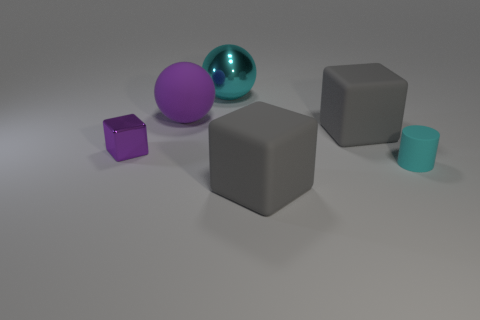There is a thing that is in front of the tiny thing that is to the right of the big matte object left of the big cyan metallic object; what shape is it?
Your answer should be compact. Cube. There is a metal object in front of the large cyan metallic sphere; is it the same color as the tiny matte thing in front of the metal cube?
Make the answer very short. No. There is a metal thing that is the same color as the large rubber ball; what shape is it?
Offer a terse response. Cube. There is a rubber thing in front of the small object on the right side of the purple cube that is left of the large purple object; what is its color?
Provide a succinct answer. Gray. What is the color of the other large object that is the same shape as the cyan shiny object?
Offer a very short reply. Purple. Are there any other things that have the same color as the small rubber cylinder?
Keep it short and to the point. Yes. How many other things are the same material as the cylinder?
Offer a very short reply. 3. The metal cube has what size?
Keep it short and to the point. Small. Is there a big cyan metallic thing that has the same shape as the purple metallic object?
Give a very brief answer. No. What number of things are metal balls or cubes that are in front of the small shiny object?
Offer a terse response. 2. 